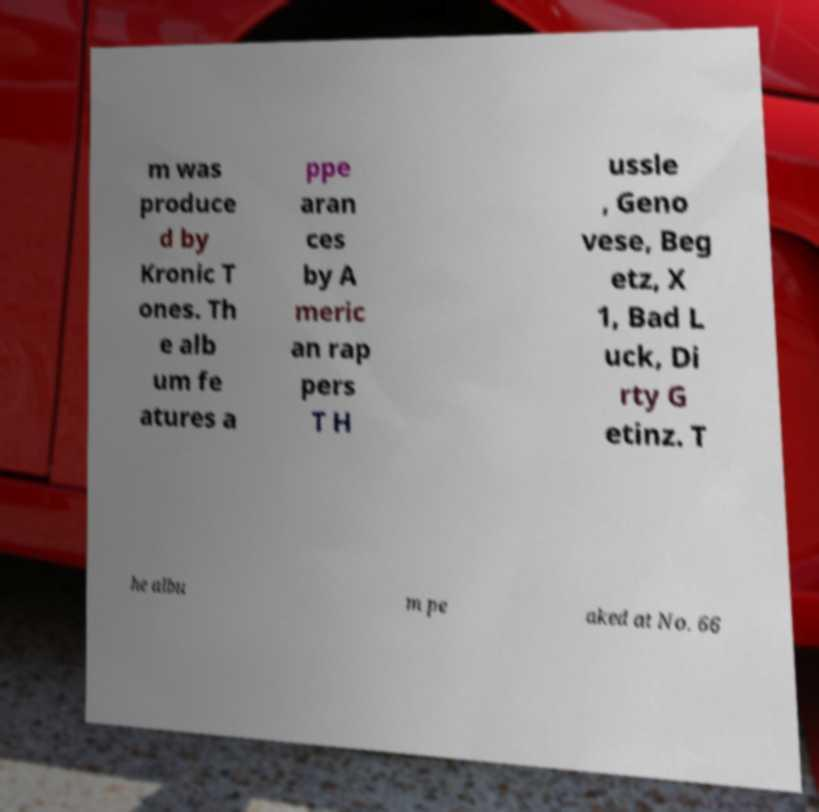Please identify and transcribe the text found in this image. m was produce d by Kronic T ones. Th e alb um fe atures a ppe aran ces by A meric an rap pers T H ussle , Geno vese, Beg etz, X 1, Bad L uck, Di rty G etinz. T he albu m pe aked at No. 66 